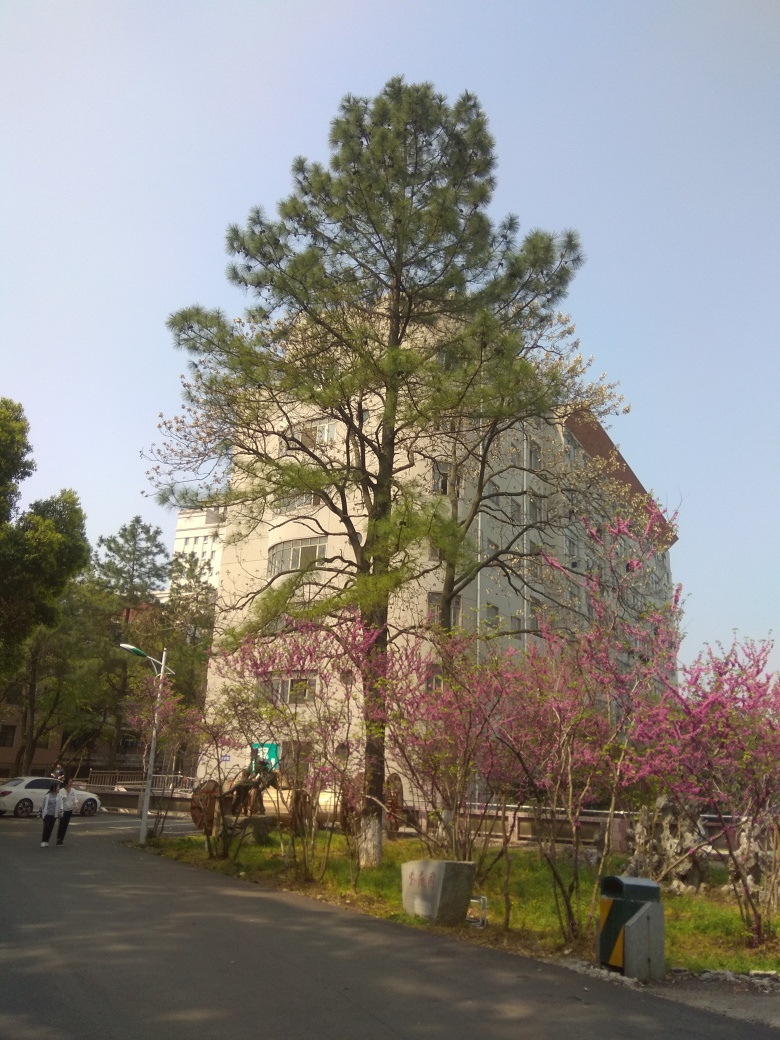What does the environment in the image suggest about the location? The environment in the image suggests a well-maintained urban or suburban setting, likely part of a university campus, public park, or civic area given the wide paved path, managed landscaping, and appearance of the building. The mix of coniferous and blossoming trees could indicate a temperate climate zone. 